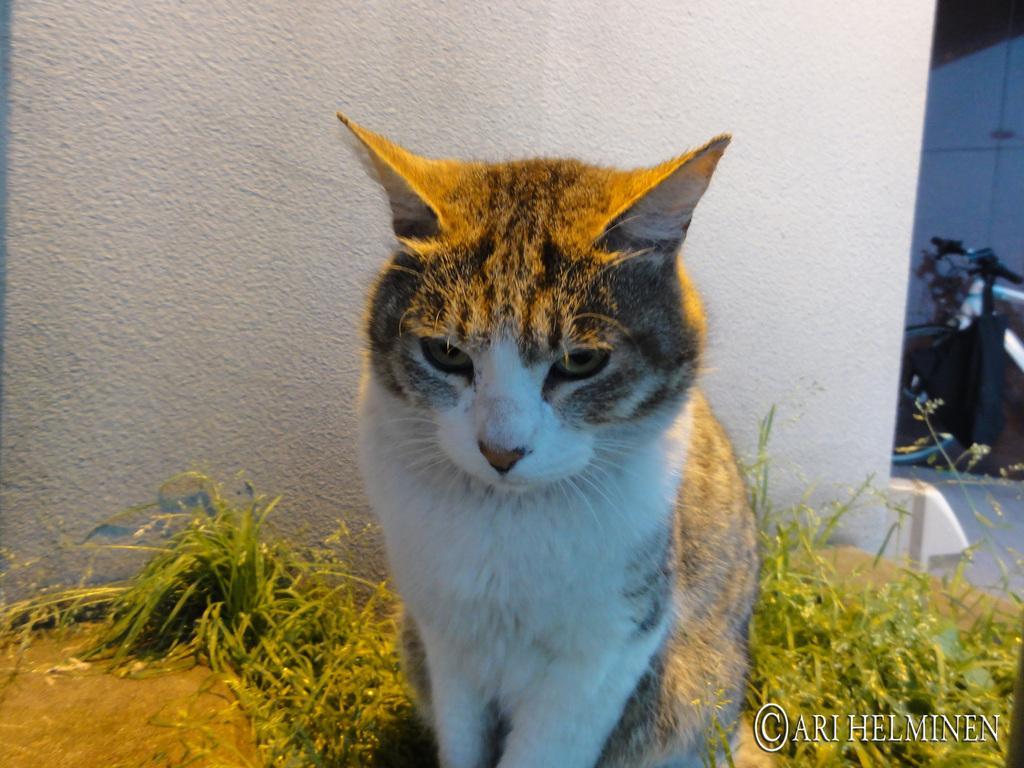In one or two sentences, can you explain what this image depicts? In this picture we can see a cat , grass, wall and in the background we can see an object on the ground. 